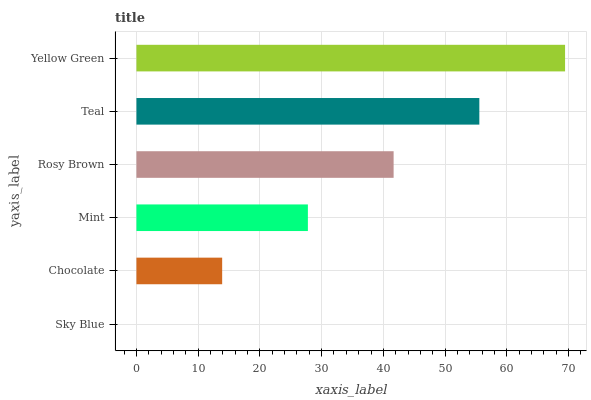Is Sky Blue the minimum?
Answer yes or no. Yes. Is Yellow Green the maximum?
Answer yes or no. Yes. Is Chocolate the minimum?
Answer yes or no. No. Is Chocolate the maximum?
Answer yes or no. No. Is Chocolate greater than Sky Blue?
Answer yes or no. Yes. Is Sky Blue less than Chocolate?
Answer yes or no. Yes. Is Sky Blue greater than Chocolate?
Answer yes or no. No. Is Chocolate less than Sky Blue?
Answer yes or no. No. Is Rosy Brown the high median?
Answer yes or no. Yes. Is Mint the low median?
Answer yes or no. Yes. Is Sky Blue the high median?
Answer yes or no. No. Is Teal the low median?
Answer yes or no. No. 